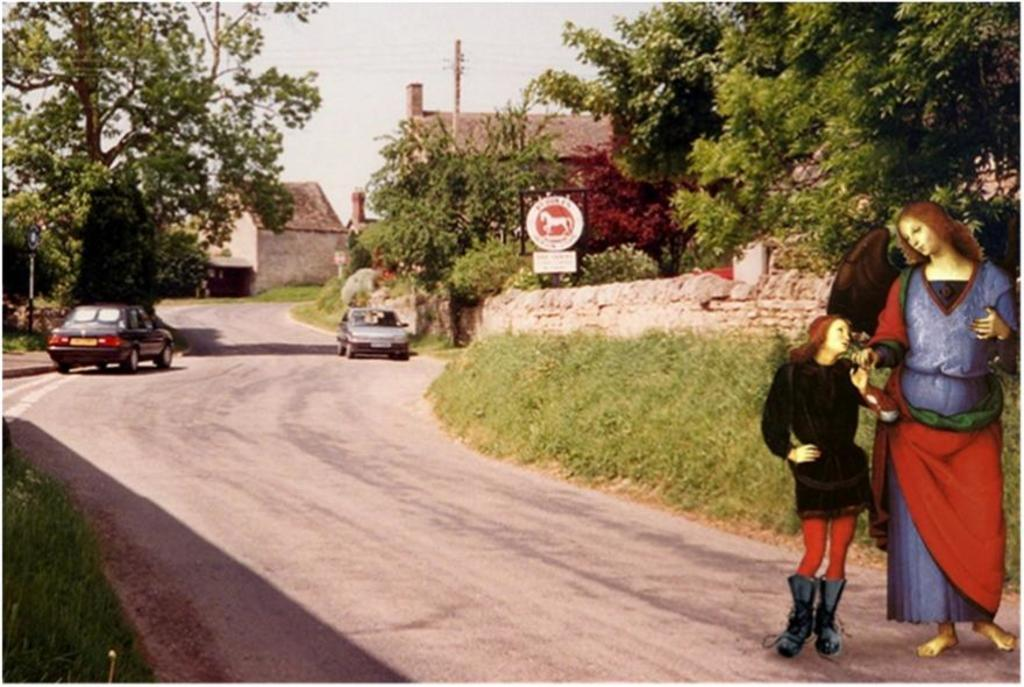What can be seen on the road in the image? There are vehicles on the road in the image. What type of natural elements are present in the image? There are trees in the image. What type of structures can be seen in the image? There are houses in the image. What are the people in the image doing? People are standing in the image. What is visible in the background of the image? The sky is visible in the image. Where is the bed located in the image? There is no bed present in the image. How many frogs can be seen hopping on the road in the image? There are no frogs present in the image. 